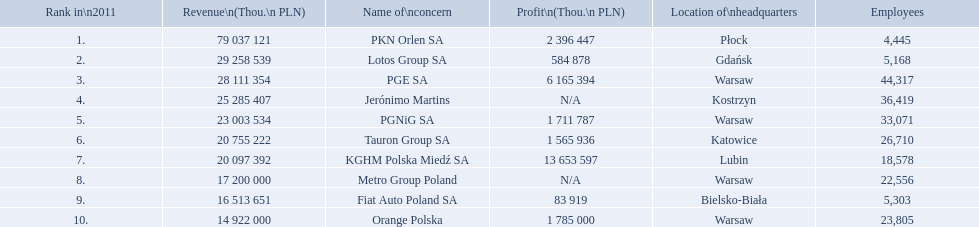What is the number of employees that work for pkn orlen sa in poland? 4,445. What number of employees work for lotos group sa? 5,168. How many people work for pgnig sa? 33,071. 